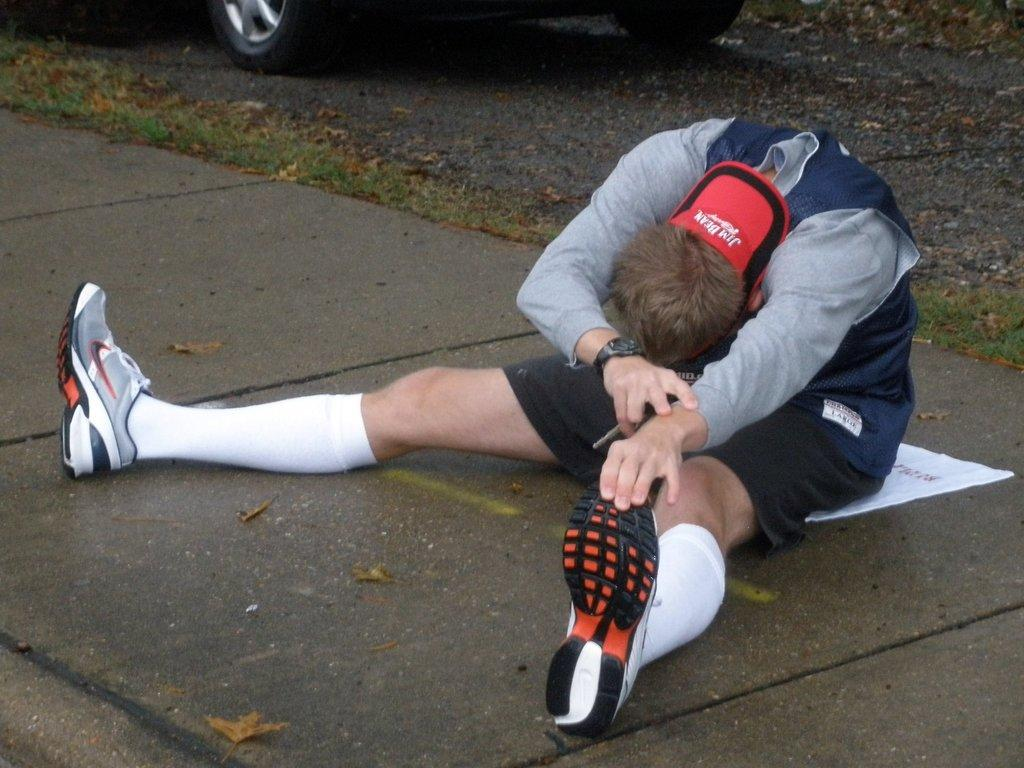Who is present in the image? There is a man in the image. What is the man sitting on? The man is seated on a cloth. What can be seen behind the man? There is a car behind the man. What type of natural environment is visible in the image? There is grass visible in the image. What type of apparel is the woman wearing in the image? There is no woman present in the image, so it is not possible to answer that question. 